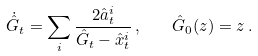Convert formula to latex. <formula><loc_0><loc_0><loc_500><loc_500>\dot { \hat { G } } _ { t } = \sum _ { i } \frac { 2 \hat { a } _ { t } ^ { i } } { \hat { G } _ { t } - \hat { x } _ { t } ^ { i } } \, , \quad \hat { G } _ { 0 } ( z ) = z \, .</formula> 